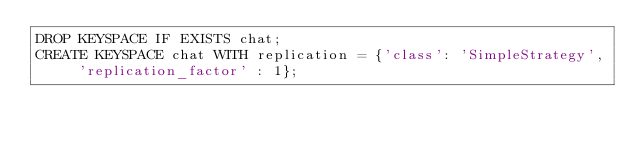<code> <loc_0><loc_0><loc_500><loc_500><_SQL_>DROP KEYSPACE IF EXISTS chat;
CREATE KEYSPACE chat WITH replication = {'class': 'SimpleStrategy', 'replication_factor' : 1};
</code> 